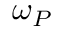Convert formula to latex. <formula><loc_0><loc_0><loc_500><loc_500>\omega _ { P }</formula> 